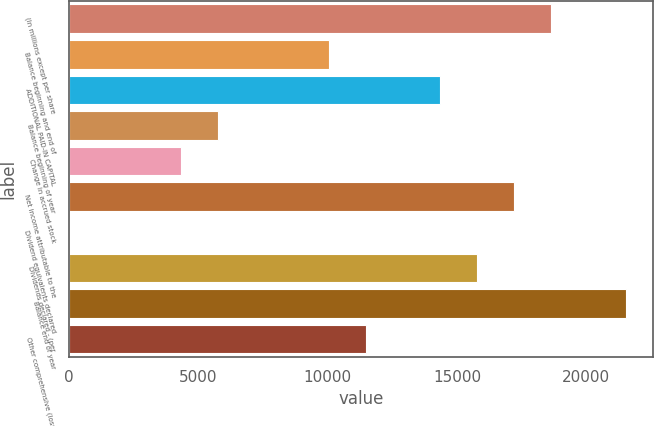Convert chart. <chart><loc_0><loc_0><loc_500><loc_500><bar_chart><fcel>(In millions except per share<fcel>Balance beginning and end of<fcel>ADDITIONAL PAID-IN CAPITAL<fcel>Balance beginning of year<fcel>Change in accrued stock<fcel>Net income attributable to the<fcel>Dividend equivalents declared<fcel>Dividends declared - (per<fcel>Balance end of year<fcel>Other comprehensive (loss)<nl><fcel>18649<fcel>10045<fcel>14347<fcel>5743<fcel>4309<fcel>17215<fcel>7<fcel>15781<fcel>21517<fcel>11479<nl></chart> 